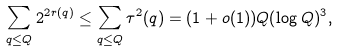Convert formula to latex. <formula><loc_0><loc_0><loc_500><loc_500>\sum _ { q \leq Q } 2 ^ { 2 r ( q ) } \leq \sum _ { q \leq Q } \tau ^ { 2 } ( q ) = ( 1 + o ( 1 ) ) Q ( \log Q ) ^ { 3 } ,</formula> 